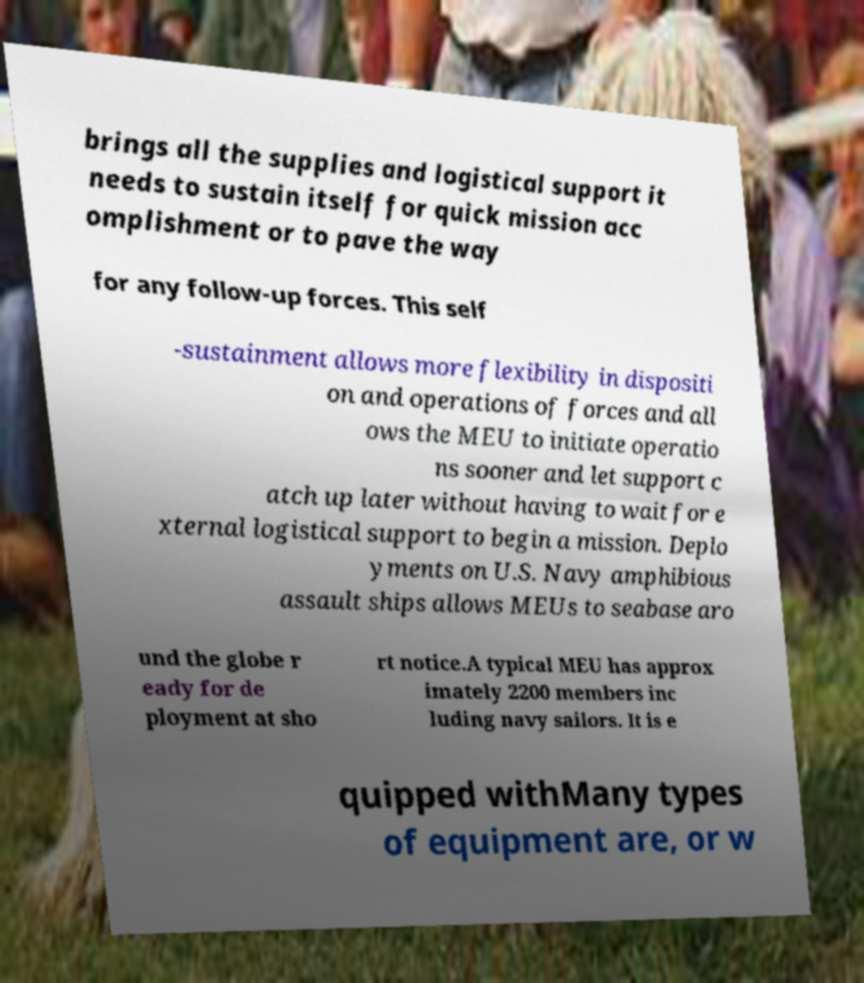For documentation purposes, I need the text within this image transcribed. Could you provide that? brings all the supplies and logistical support it needs to sustain itself for quick mission acc omplishment or to pave the way for any follow-up forces. This self -sustainment allows more flexibility in dispositi on and operations of forces and all ows the MEU to initiate operatio ns sooner and let support c atch up later without having to wait for e xternal logistical support to begin a mission. Deplo yments on U.S. Navy amphibious assault ships allows MEUs to seabase aro und the globe r eady for de ployment at sho rt notice.A typical MEU has approx imately 2200 members inc luding navy sailors. It is e quipped withMany types of equipment are, or w 